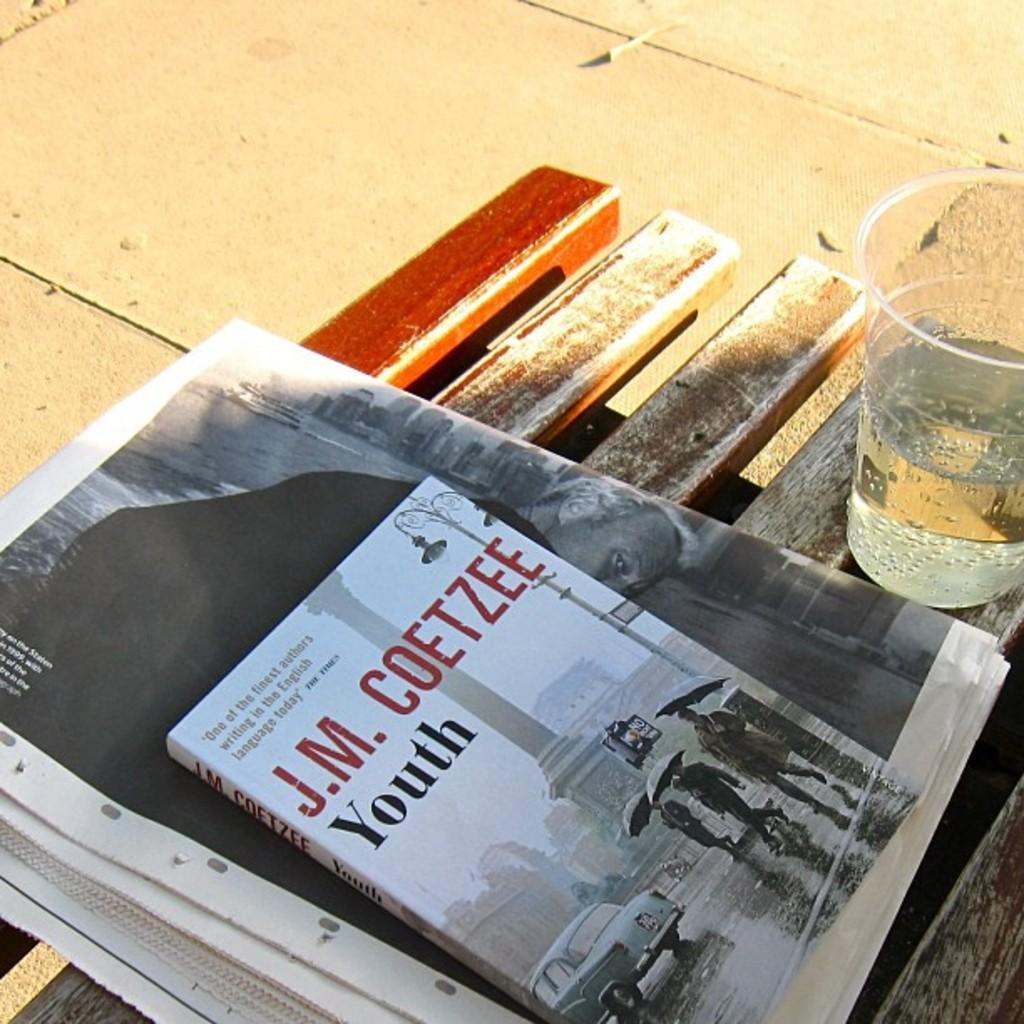<image>
Write a terse but informative summary of the picture. A copy of Youth by J.M. Coetzee sits on top of a newspaper on a table. 